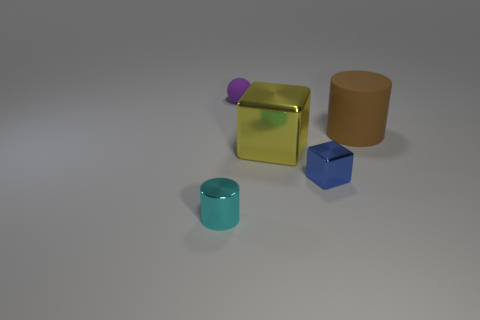There is a tiny thing on the right side of the tiny purple matte ball; does it have the same shape as the matte object that is on the right side of the large yellow cube? Upon inspecting the image, we can see that the tiny object near the small purple matte ball is, in fact, spherical and therefore does not share the same shape as the matte blue cube positioned to the right of the large yellow cube, which is cubic. 